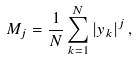Convert formula to latex. <formula><loc_0><loc_0><loc_500><loc_500>M _ { j } = \frac { 1 } { N } \sum _ { k = 1 } ^ { N } \left | y _ { k } \right | ^ { j } ,</formula> 